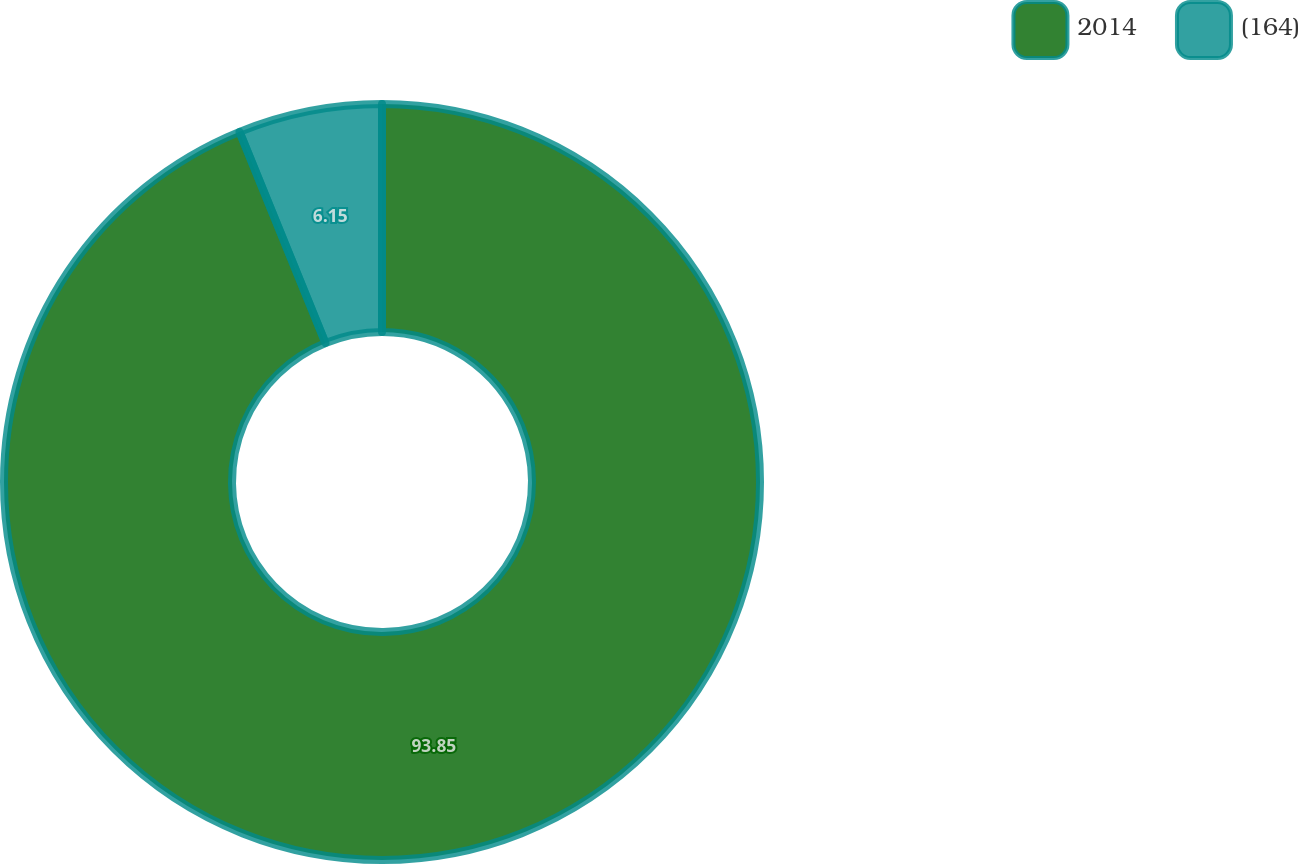Convert chart. <chart><loc_0><loc_0><loc_500><loc_500><pie_chart><fcel>2014<fcel>(164)<nl><fcel>93.85%<fcel>6.15%<nl></chart> 